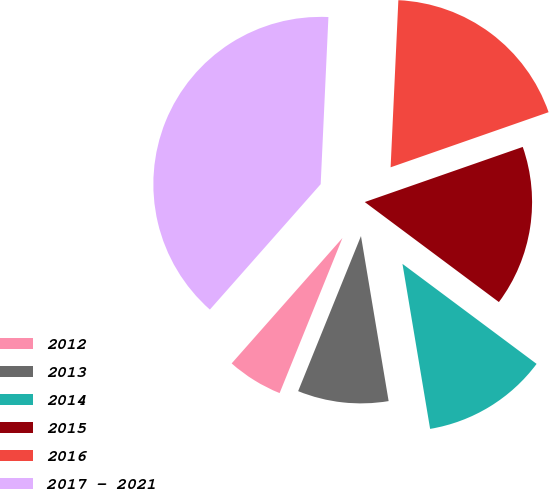Convert chart to OTSL. <chart><loc_0><loc_0><loc_500><loc_500><pie_chart><fcel>2012<fcel>2013<fcel>2014<fcel>2015<fcel>2016<fcel>2017 - 2021<nl><fcel>5.39%<fcel>8.77%<fcel>12.16%<fcel>15.54%<fcel>18.92%<fcel>39.22%<nl></chart> 